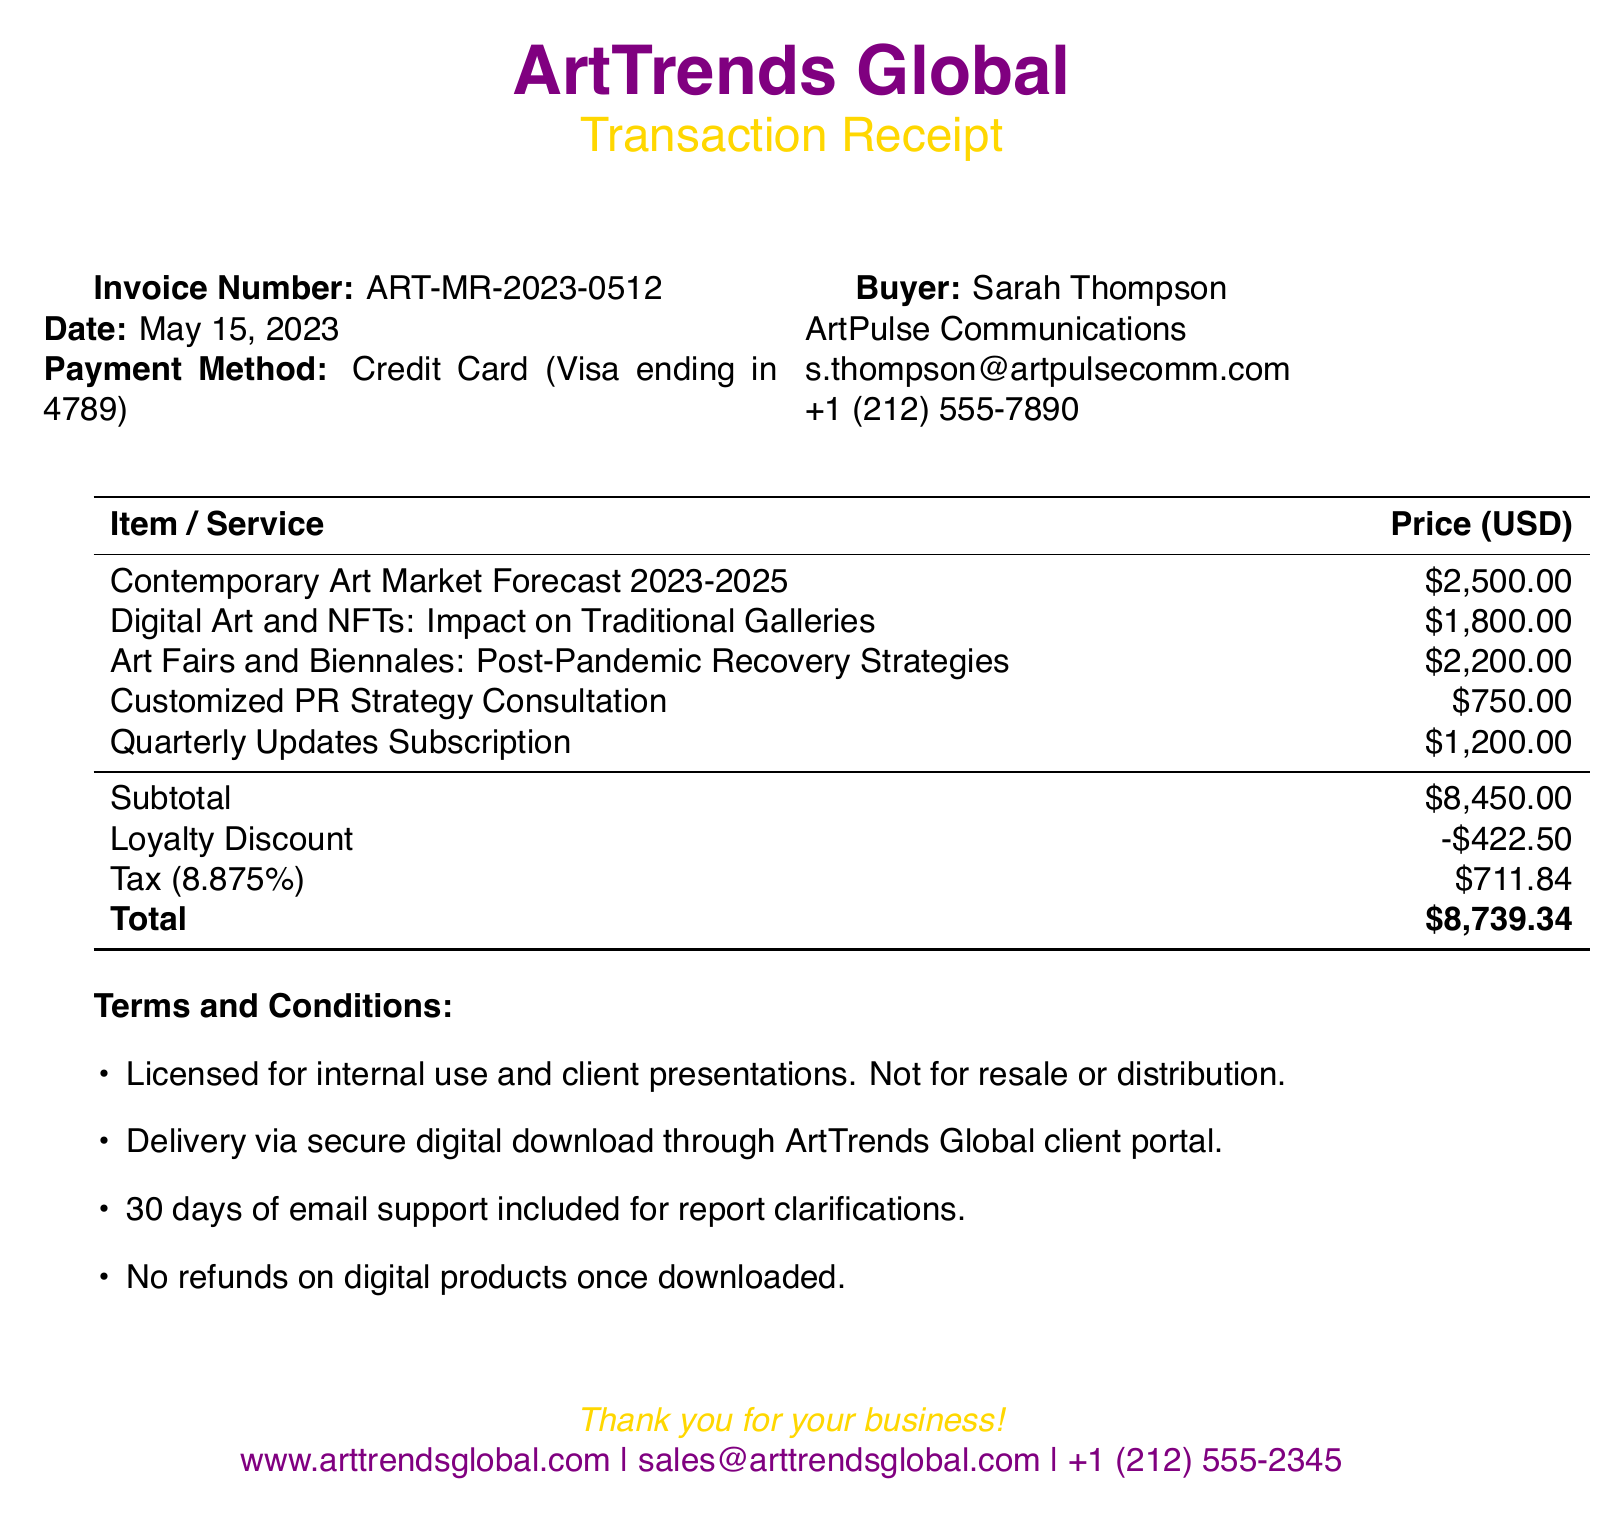What is the invoice number? The invoice number is listed in the document under transaction details.
Answer: ART-MR-2023-0512 What is the total amount paid? The total amount is computed from the pricing summary section.
Answer: $8,739.34 Who is the buyer's company? The buyer's company is mentioned alongside the buyer's name and position.
Answer: ArtPulse Communications What is the date of the transaction? The date is specified in the transaction details.
Answer: May 15, 2023 What type of payment method was used? The payment method is explicitly stated in the transaction details.
Answer: Credit Card (Visa ending in 4789) What is the loyalty discount amount? The loyalty discount is included in the pricing summary with a detailed description.
Answer: $422.50 What is included in the support terms? The support details outline the provisions available to the buyer, as stated in the terms and conditions.
Answer: 30 days of email support included for report clarifications What does the report on Digital Art and NFTs focus on? The description for this report provides insight into its content and scope.
Answer: Impact on Traditional Galleries How long is the Quarterly Updates Subscription valid for? The duration of the subscription is inferred from its description in the additional services.
Answer: One year What are the relevant exhibitions mentioned? The relevant exhibitions are listed under the industry context section for market insights.
Answer: Venice Biennale 2023, Art Basel Miami Beach, Frieze London 